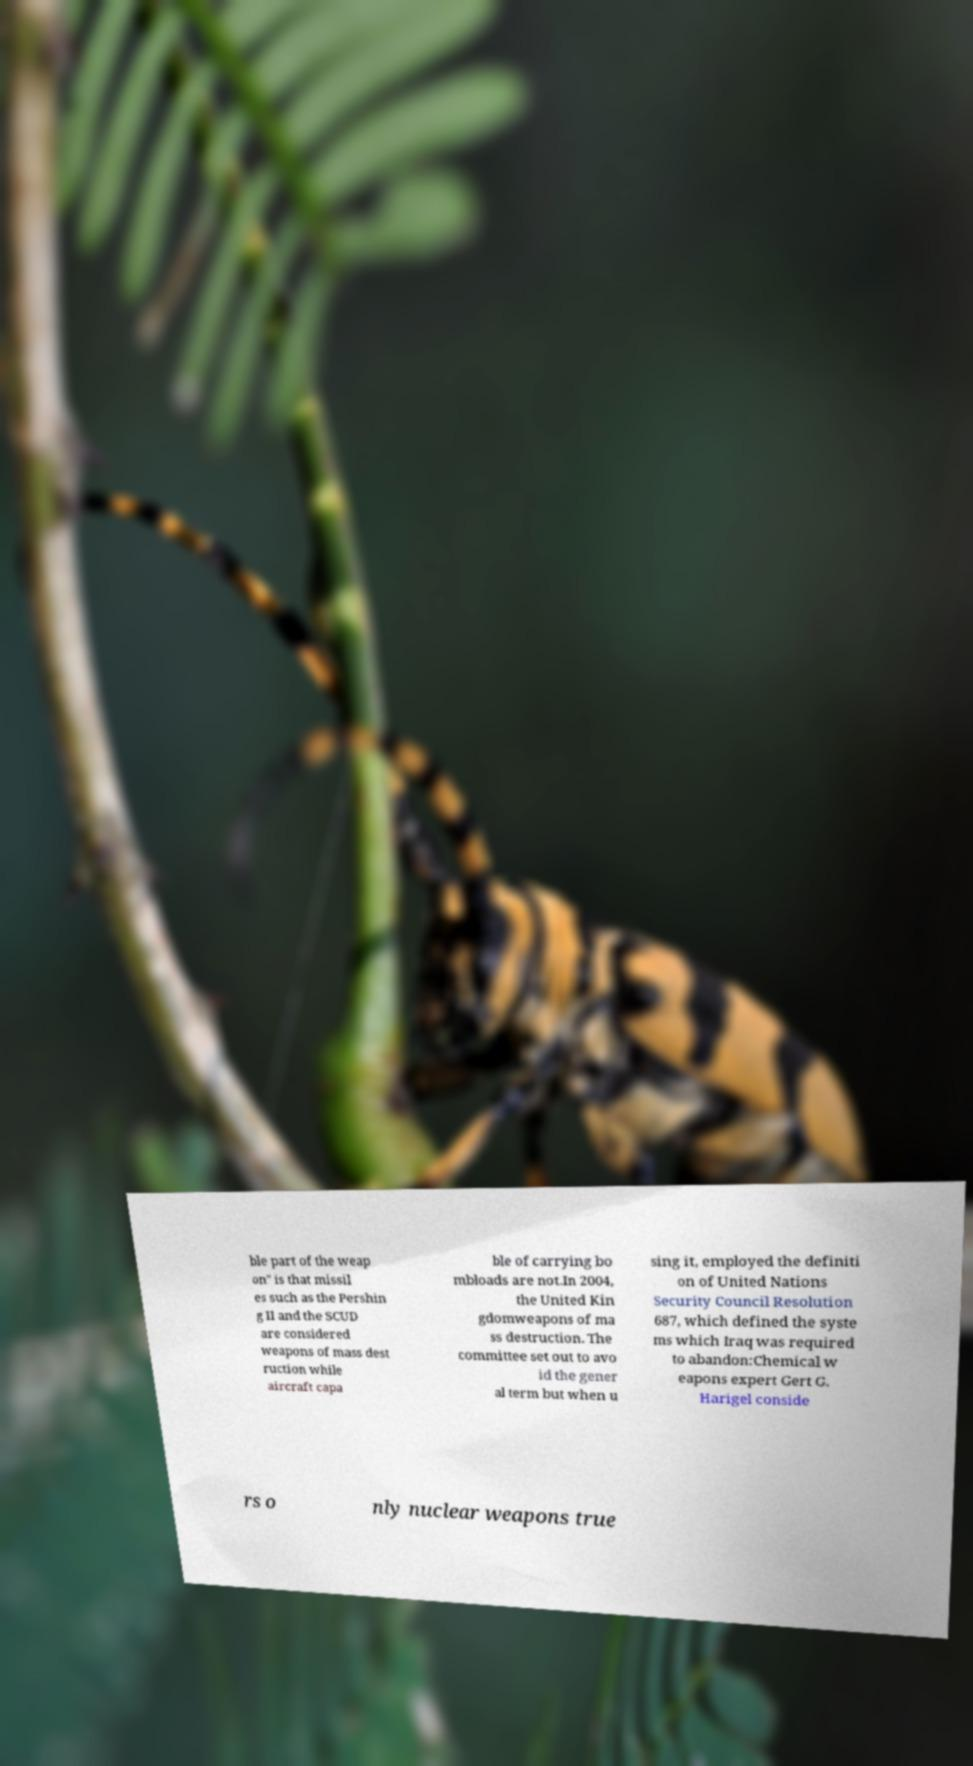Can you accurately transcribe the text from the provided image for me? ble part of the weap on" is that missil es such as the Pershin g II and the SCUD are considered weapons of mass dest ruction while aircraft capa ble of carrying bo mbloads are not.In 2004, the United Kin gdomweapons of ma ss destruction. The committee set out to avo id the gener al term but when u sing it, employed the definiti on of United Nations Security Council Resolution 687, which defined the syste ms which Iraq was required to abandon:Chemical w eapons expert Gert G. Harigel conside rs o nly nuclear weapons true 